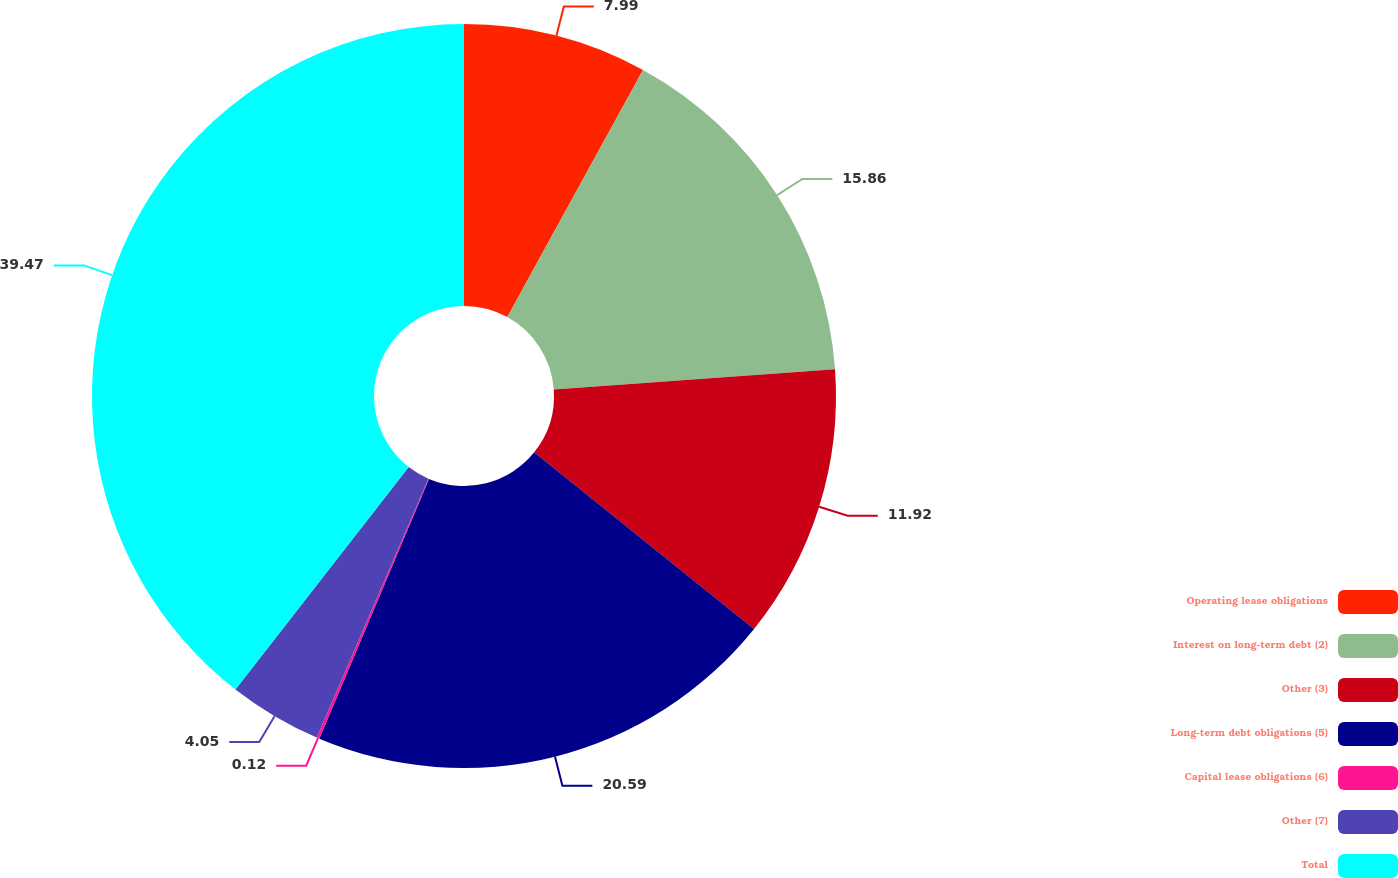<chart> <loc_0><loc_0><loc_500><loc_500><pie_chart><fcel>Operating lease obligations<fcel>Interest on long-term debt (2)<fcel>Other (3)<fcel>Long-term debt obligations (5)<fcel>Capital lease obligations (6)<fcel>Other (7)<fcel>Total<nl><fcel>7.99%<fcel>15.86%<fcel>11.92%<fcel>20.59%<fcel>0.12%<fcel>4.05%<fcel>39.47%<nl></chart> 